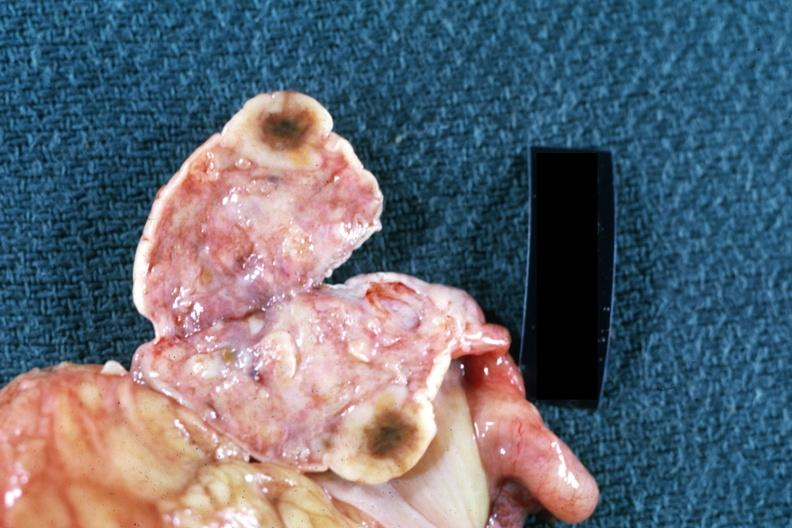what is close-up single lesion shown?
Answer the question using a single word or phrase. Lesion shown breast primary 